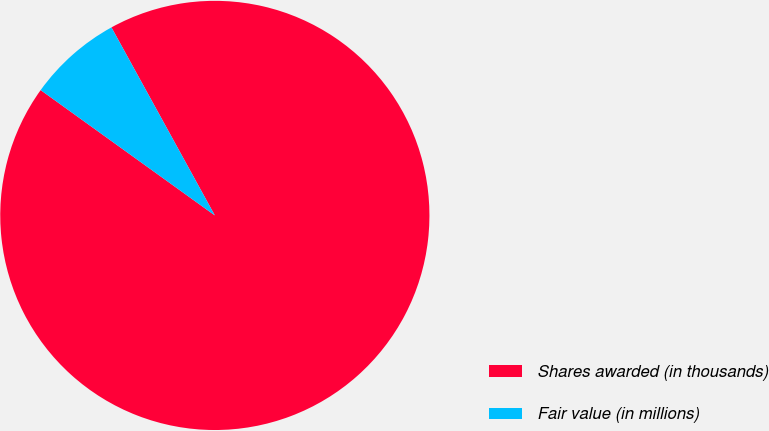Convert chart to OTSL. <chart><loc_0><loc_0><loc_500><loc_500><pie_chart><fcel>Shares awarded (in thousands)<fcel>Fair value (in millions)<nl><fcel>92.93%<fcel>7.07%<nl></chart> 